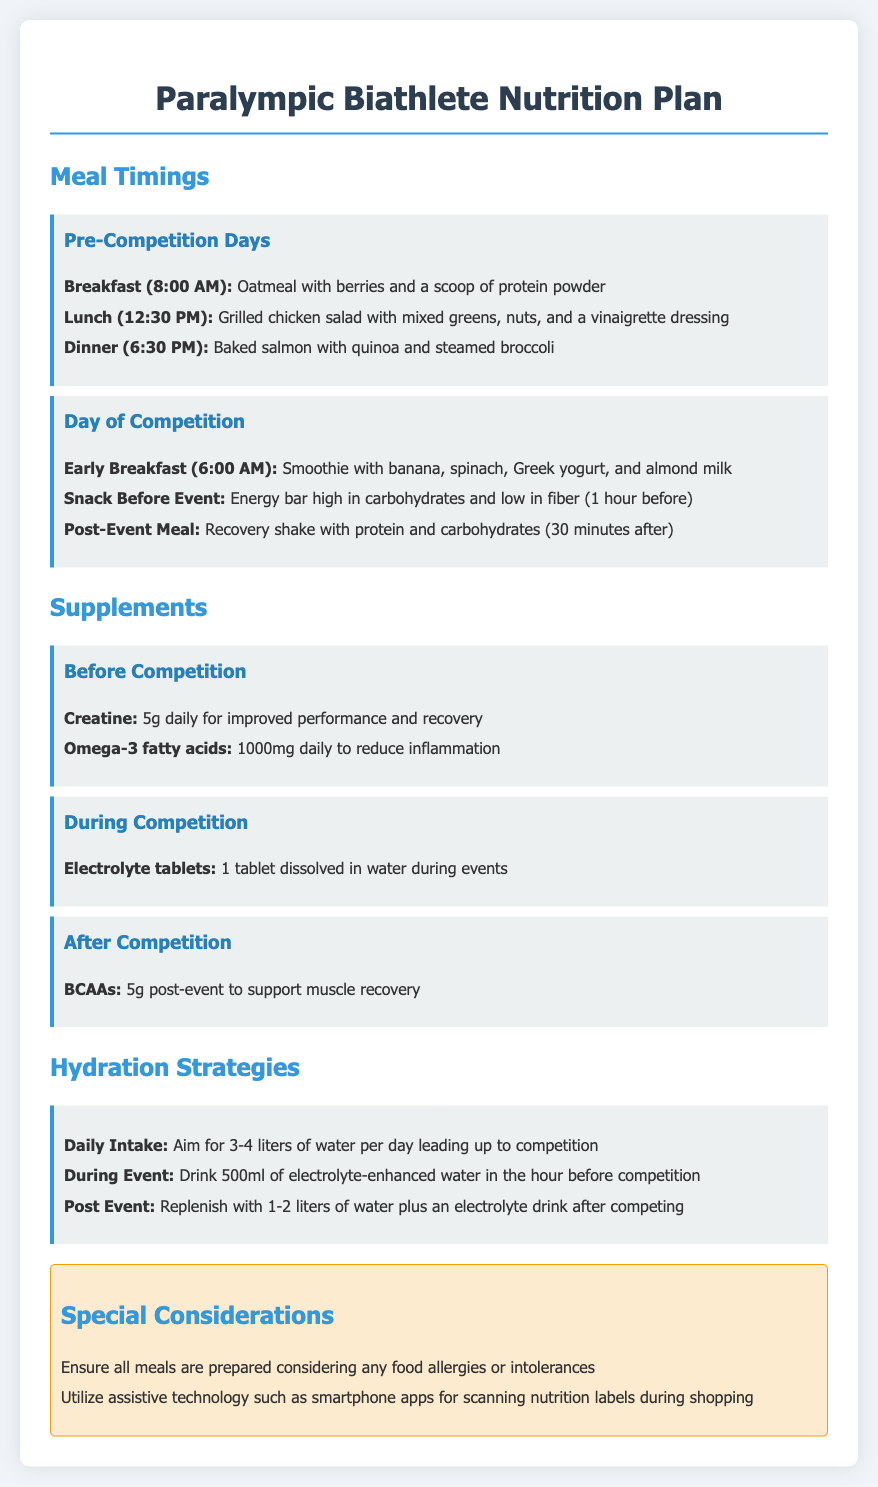what is the breakfast meal on the day of competition? The breakfast meal is specified as a smoothie with banana, spinach, Greek yogurt, and almond milk.
Answer: smoothie with banana, spinach, Greek yogurt, and almond milk how many liters of water should be consumed daily leading up to competition? The document states the daily intake should aim for 3-4 liters of water per day.
Answer: 3-4 liters what supplement is taken daily before competition? The document mentions creatine as a supplement taken daily before competition.
Answer: Creatine when should the post-event meal be eaten? The post-event meal should be consumed 30 minutes after the event, according to the document.
Answer: 30 minutes after which electrolyte source is used during competition? The document suggests using electrolyte tablets dissolved in water during events as the source of electrolytes.
Answer: Electrolyte tablets what is one special consideration mentioned in the document? The document mentions ensuring meals are prepared considering any food allergies or intolerances as a special consideration.
Answer: food allergies or intolerances what is the suggested lunch option before the competition? The lunch option mentioned is a grilled chicken salad with mixed greens, nuts, and a vinaigrette dressing.
Answer: grilled chicken salad with mixed greens, nuts, and a vinaigrette dressing how many grams of BCAAs are recommended after competition? It is recommended to take 5 grams of BCAAs post-event to support muscle recovery.
Answer: 5 grams what time is the dinner scheduled on pre-competition days? The dinner is scheduled for 6:30 PM on pre-competition days, as stated in the document.
Answer: 6:30 PM 